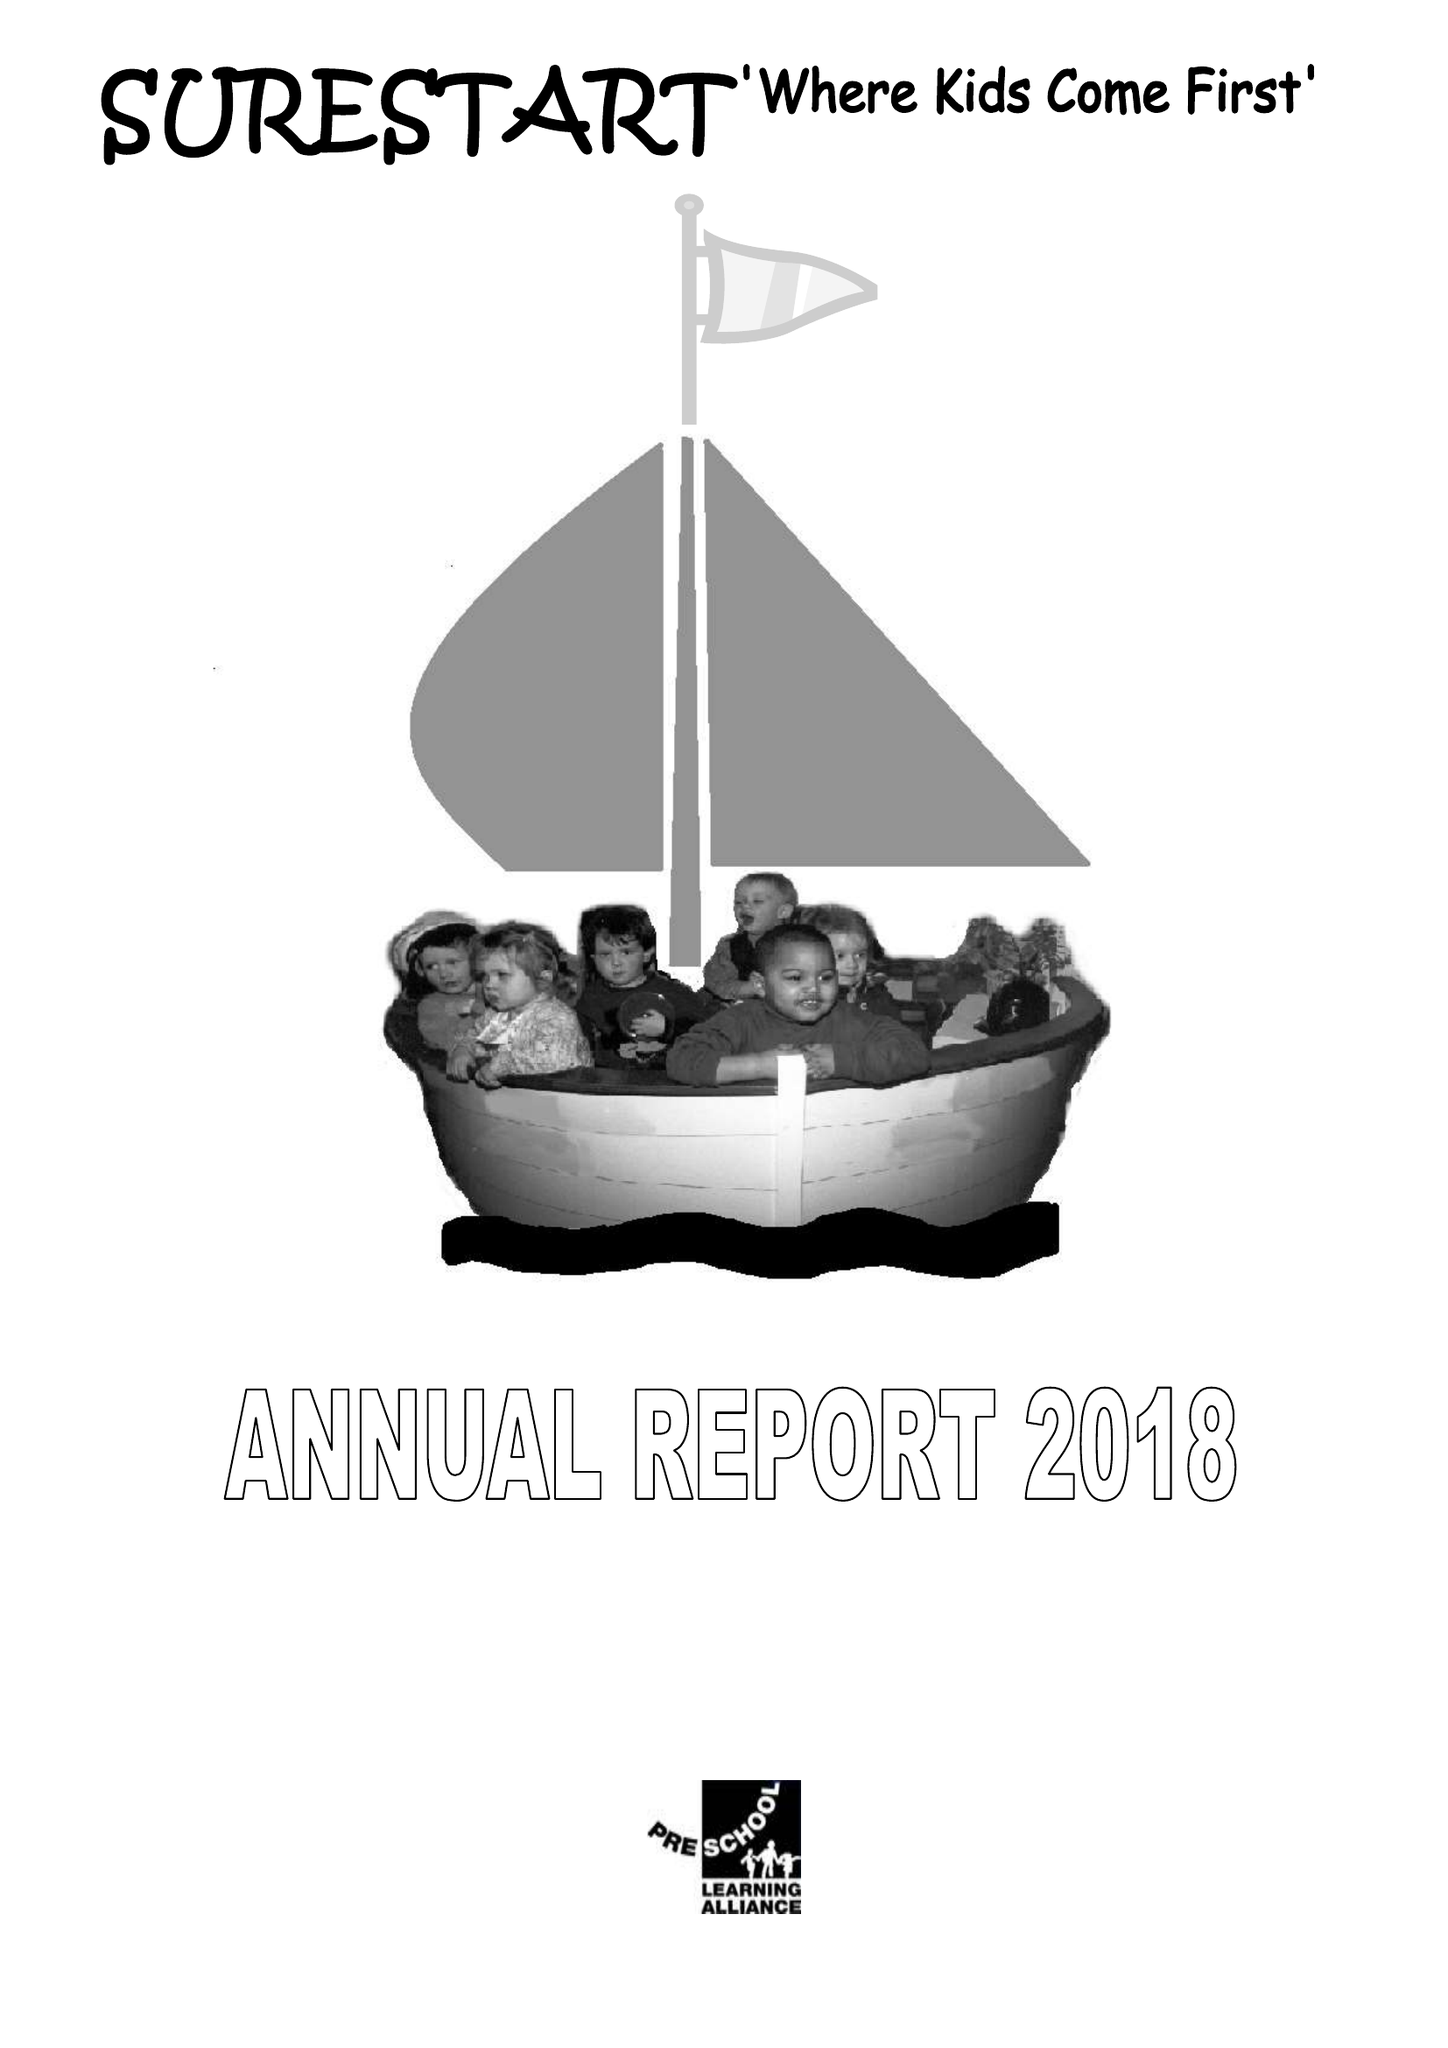What is the value for the address__postcode?
Answer the question using a single word or phrase. None 